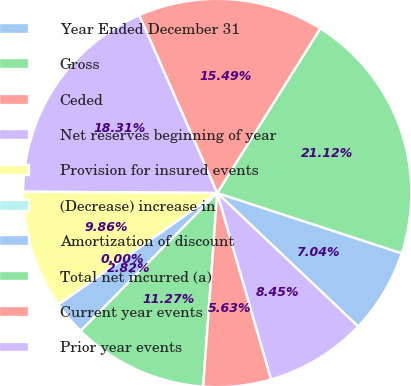Convert chart to OTSL. <chart><loc_0><loc_0><loc_500><loc_500><pie_chart><fcel>Year Ended December 31<fcel>Gross<fcel>Ceded<fcel>Net reserves beginning of year<fcel>Provision for insured events<fcel>(Decrease) increase in<fcel>Amortization of discount<fcel>Total net incurred (a)<fcel>Current year events<fcel>Prior year events<nl><fcel>7.04%<fcel>21.12%<fcel>15.49%<fcel>18.31%<fcel>9.86%<fcel>0.0%<fcel>2.82%<fcel>11.27%<fcel>5.63%<fcel>8.45%<nl></chart> 